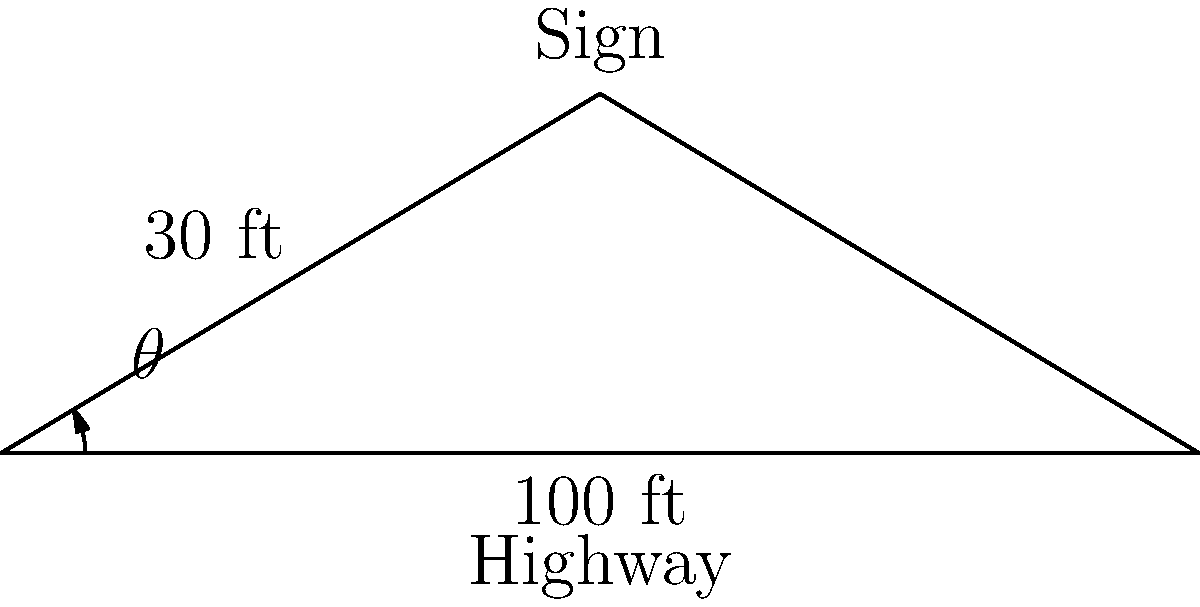You want to place a new sign for your business along the highway. The sign will be 30 feet from the edge of the highway and 100 feet from the point directly below it on the highway. What is the optimal viewing angle $\theta$ for drivers to see your sign? To find the optimal viewing angle $\theta$, we can use the trigonometric relationship in the right triangle formed by the sign, its base on the highway, and the viewing point. Let's solve this step-by-step:

1) We have a right triangle with:
   - The adjacent side (along the highway) = 100 ft
   - The opposite side (height of the sign) = 30 ft

2) To find the angle $\theta$, we can use the arctangent function:

   $\theta = \arctan(\frac{\text{opposite}}{\text{adjacent}})$

3) Substituting our values:

   $\theta = \arctan(\frac{30}{100})$

4) Simplify the fraction:

   $\theta = \arctan(0.3)$

5) Calculate the arctangent:

   $\theta \approx 16.70°$

Therefore, the optimal viewing angle for drivers to see your sign is approximately 16.70 degrees.
Answer: $16.70°$ 